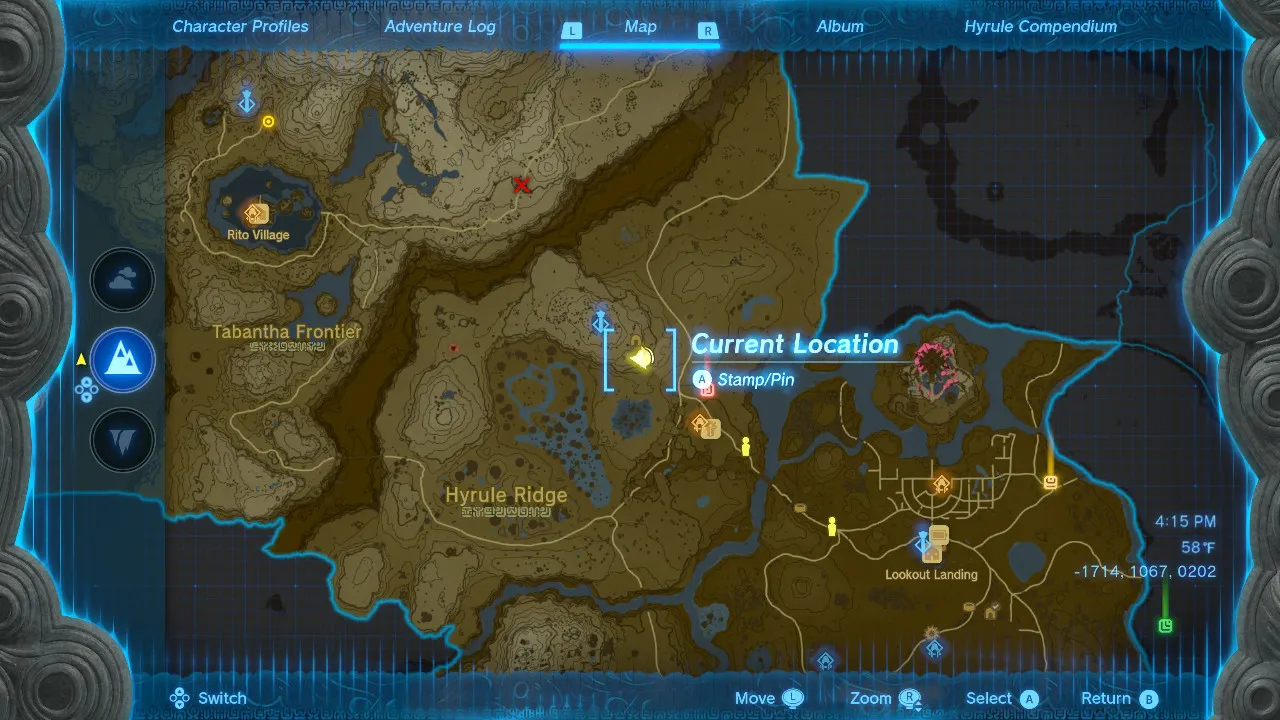Given my horse's location on this map, what is the quickest route to reach it? This image appears to be a map or navigation interface from a video game. It shows a detailed topographical map of a fictional region with various locations marked, such as Rito Village, Tabantha Frontier, Hyrule Ridge, and Lookout Landing.

Your current location seems to be indicated by the blue stamp or pin icon in the central area of the map. The image mentions your "horse's location" but I don't see a specific marker or indicator for that on the map itself.

Without knowing the exact location of your horse relative to the marked areas, it's difficult for me to recommend the quickest route. However, if you can point out where your horse is positioned on this map interface, I'd be happy to analyze the terrain and suggest an efficient path to reach that destination from your current central location. 